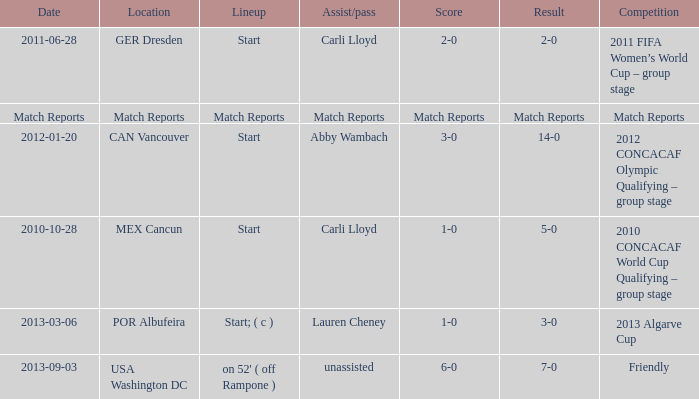Name the Result of the Lineup of start, an Assist/pass of carli lloyd, and an Competition of 2011 fifa women’s world cup – group stage? 2-0. 